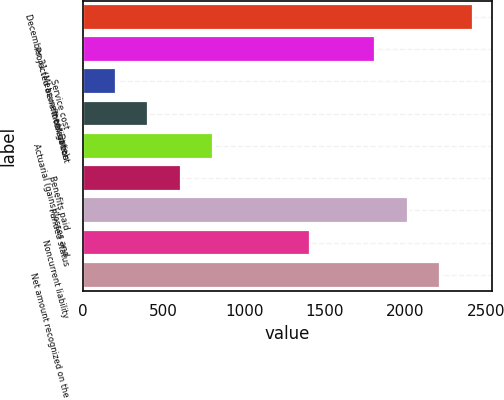Convert chart to OTSL. <chart><loc_0><loc_0><loc_500><loc_500><bar_chart><fcel>December 31 (Measurement Date)<fcel>Projected benefit obligation<fcel>Service cost<fcel>Interest cost<fcel>Actuarial (gains)/losses and<fcel>Benefits paid<fcel>Funded status<fcel>Noncurrent liability<fcel>Net amount recognized on the<nl><fcel>2416.6<fcel>1812.7<fcel>202.3<fcel>403.6<fcel>806.2<fcel>604.9<fcel>2014<fcel>1410.1<fcel>2215.3<nl></chart> 